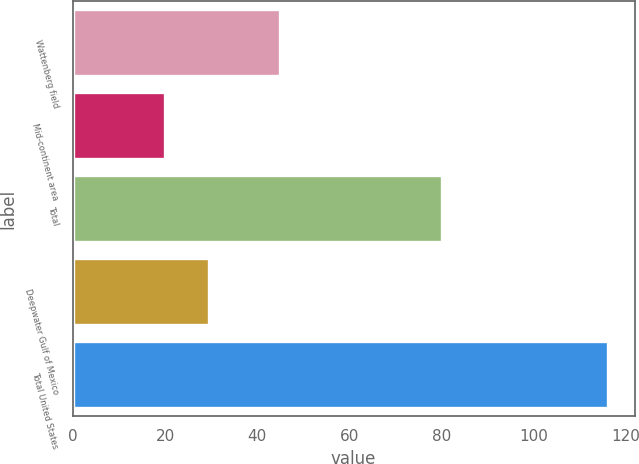<chart> <loc_0><loc_0><loc_500><loc_500><bar_chart><fcel>Wattenberg field<fcel>Mid-continent area<fcel>Total<fcel>Deepwater Gulf of Mexico<fcel>Total United States<nl><fcel>45<fcel>20<fcel>80<fcel>29.6<fcel>116<nl></chart> 